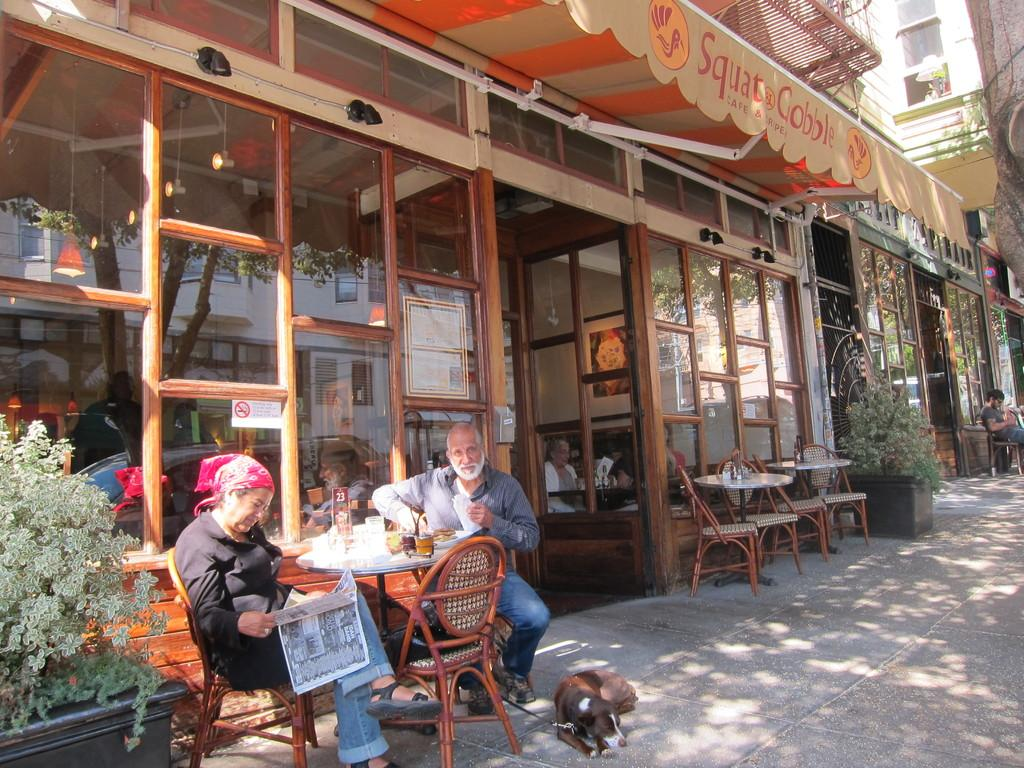How many people are in the image? There are two persons in the image. What are the persons doing in the image? The persons are sitting on chairs. What is the woman holding in the image? The woman is reading a newspaper. What other living creature is present in the image? There is a dog in the image. What type of plant can be seen in the image? There is a plant in the image. How many passengers are on the sheep in the image? A: There are no sheep or passengers present in the image. What type of dinner is being served in the image? There is no dinner being served in the image. 